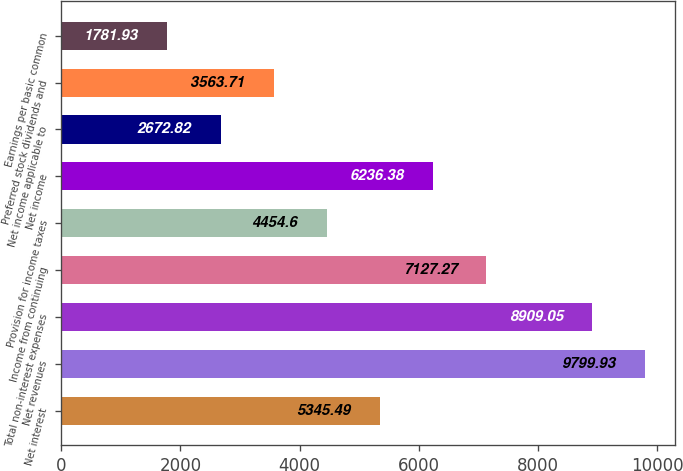<chart> <loc_0><loc_0><loc_500><loc_500><bar_chart><fcel>Net interest<fcel>Net revenues<fcel>Total non-interest expenses<fcel>Income from continuing<fcel>Provision for income taxes<fcel>Net income<fcel>Net income applicable to<fcel>Preferred stock dividends and<fcel>Earnings per basic common<nl><fcel>5345.49<fcel>9799.93<fcel>8909.05<fcel>7127.27<fcel>4454.6<fcel>6236.38<fcel>2672.82<fcel>3563.71<fcel>1781.93<nl></chart> 